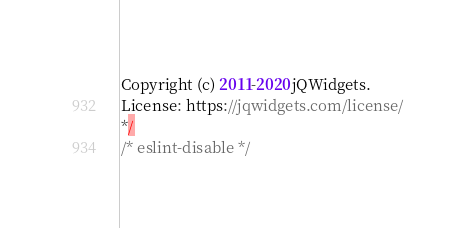Convert code to text. <code><loc_0><loc_0><loc_500><loc_500><_JavaScript_>Copyright (c) 2011-2020 jQWidgets.
License: https://jqwidgets.com/license/
*/
/* eslint-disable */
</code> 